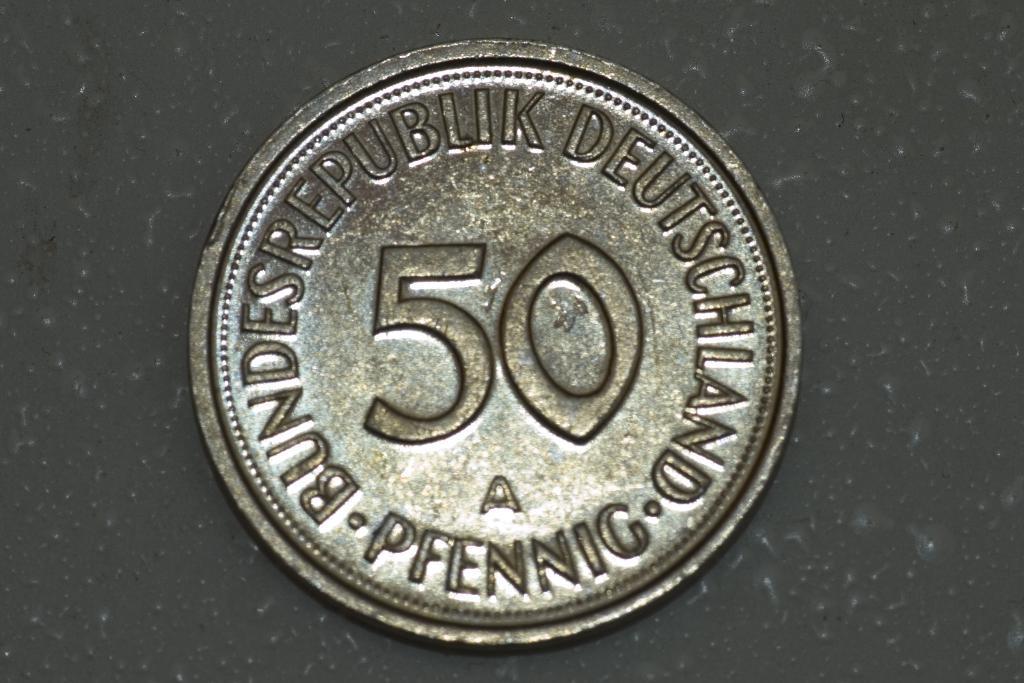Could you give a brief overview of what you see in this image? In this picture we can see a coin on a black surface. 